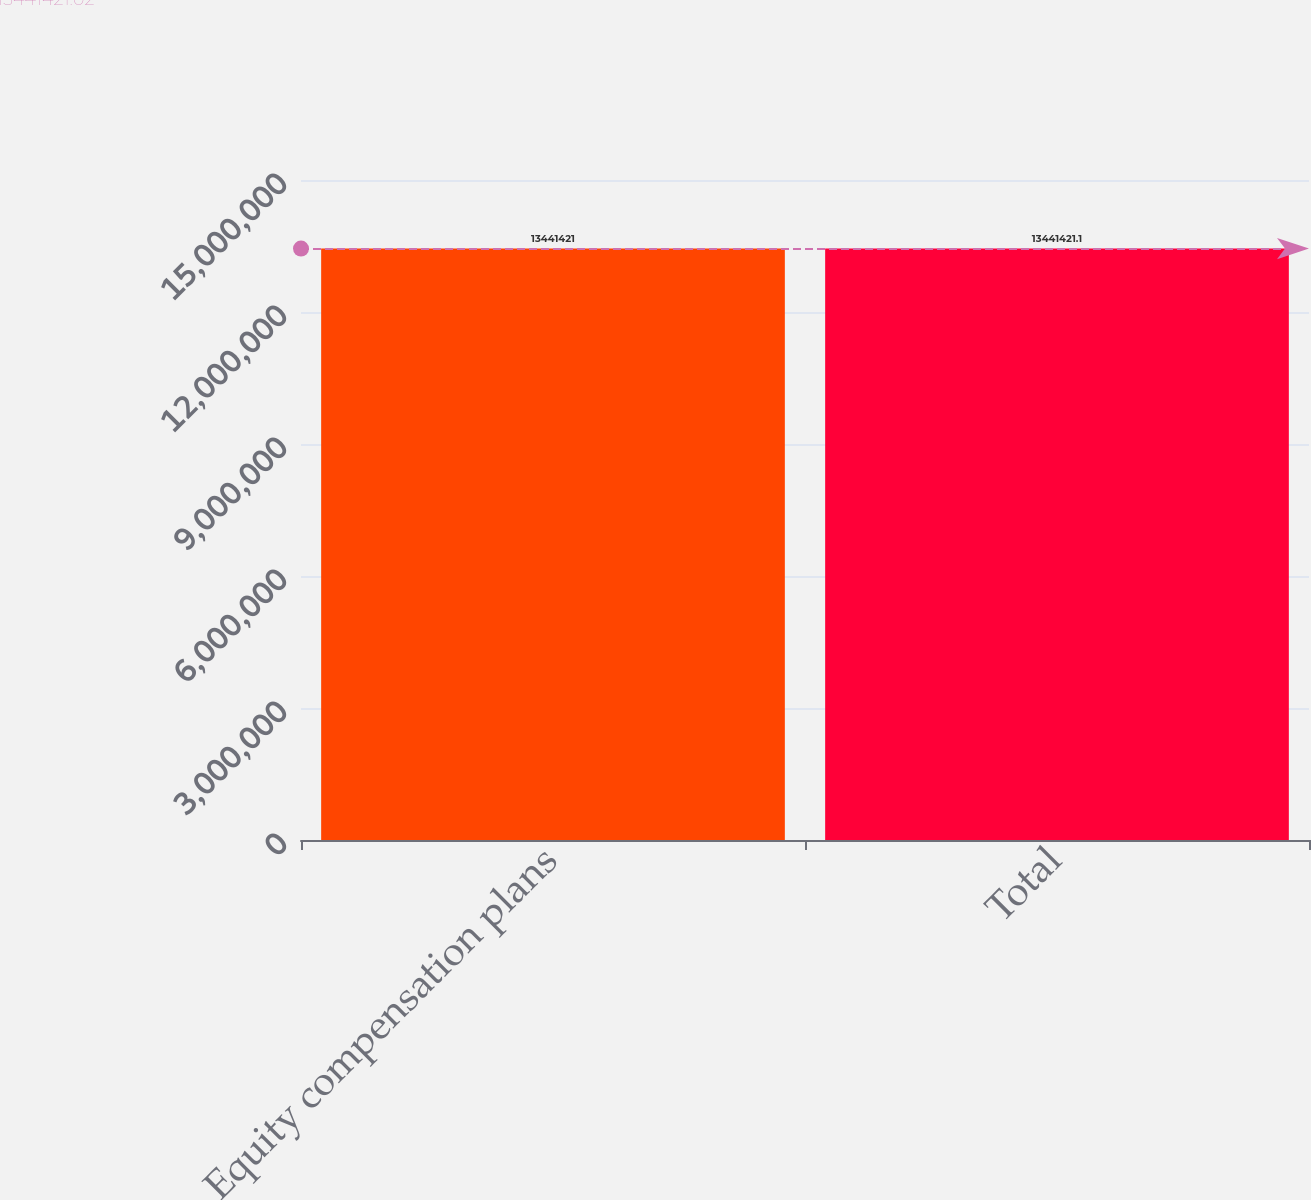<chart> <loc_0><loc_0><loc_500><loc_500><bar_chart><fcel>Equity compensation plans<fcel>Total<nl><fcel>1.34414e+07<fcel>1.34414e+07<nl></chart> 